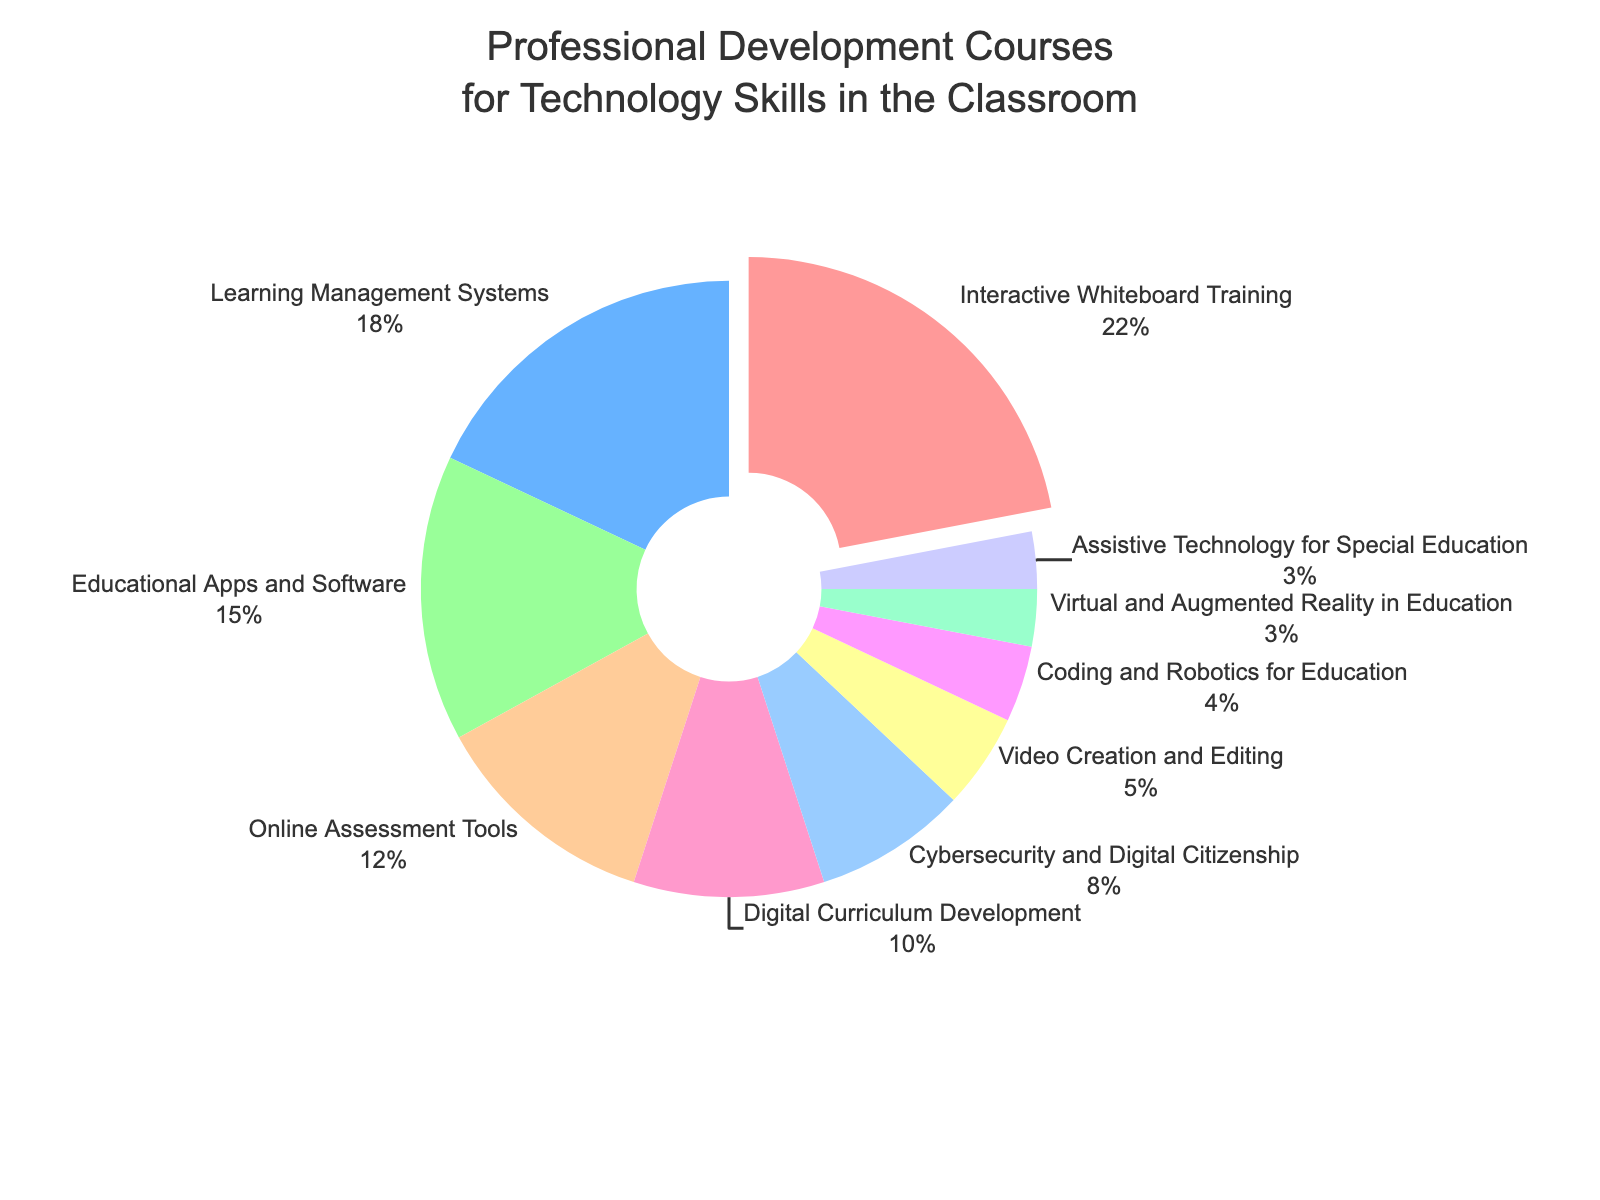Which professional development course has the highest percentage? The figure shows the distribution of percentages for various professional development courses. The course with the largest segment pulled out slightly indicates the highest percentage. By looking at this segment, we see that "Interactive Whiteboard Training" has the highest percentage.
Answer: Interactive Whiteboard Training How many courses have a percentage greater than 10%? To determine this, we need to check the percentages for each course from the figure and count how many exceed 10%. These courses are "Interactive Whiteboard Training" (22%), "Learning Management Systems" (18%), "Educational Apps and Software" (15%), and "Online Assessment Tools" (12%). There are 4 such courses.
Answer: 4 What is the combined percentage of courses related to multimedia (Video Creation and Editing, Virtual and Augmented Reality in Education)? We need to sum the percentages of "Video Creation and Editing" and "Virtual and Augmented Reality in Education" from the figure. These are 5% and 3%, respectively. Adding them gives 5% + 3% = 8%.
Answer: 8% Which two courses have the smallest representation, and what are their percentages? To identify the two courses with the smallest representation, look at the smallest segments in the pie chart. These are "Virtual and Augmented Reality in Education" and "Assistive Technology for Special Education," each with 3%.
Answer: Virtual and Augmented Reality in Education, Assistive Technology for Special Education - 3% What is the difference in percentage between the courses "Cybersecurity and Digital Citizenship" and "Online Assessment Tools"? From the pie chart, we note the percentages of "Cybersecurity and Digital Citizenship" (8%) and "Online Assessment Tools" (12%). The difference is calculated as 12% - 8% = 4%.
Answer: 4% If we combine the percentages of all courses with less than 5%, what is the total? Identify the courses with percentages less than 5% and sum their percentages. The courses are "Coding and Robotics for Education" (4%), "Virtual and Augmented Reality in Education" (3%), and "Assistive Technology for Special Education" (3%). Their combined percentage is 4% + 3% + 3% = 10%.
Answer: 10% Which course segment is colored blue, and what percentage does it represent? Look at the figure to identify the blue-colored segment, which represents "Learning Management Systems" at 18%.
Answer: Learning Management Systems - 18% What is the average percentage of the top three professional development courses? First, find the percentages of the top three courses: "Interactive Whiteboard Training" (22%), "Learning Management Systems" (18%), and "Educational Apps and Software" (15%). Sum these values: 22% + 18% + 15% = 55%. Divide by 3 to get the average: 55% / 3 ≈ 18.33%.
Answer: 18.33% Which course related to technology security has been taken by 8% of teachers? By examining the chart, "Cybersecurity and Digital Citizenship" is the course associated with technology security and is represented by 8%.
Answer: Cybersecurity and Digital Citizenship 